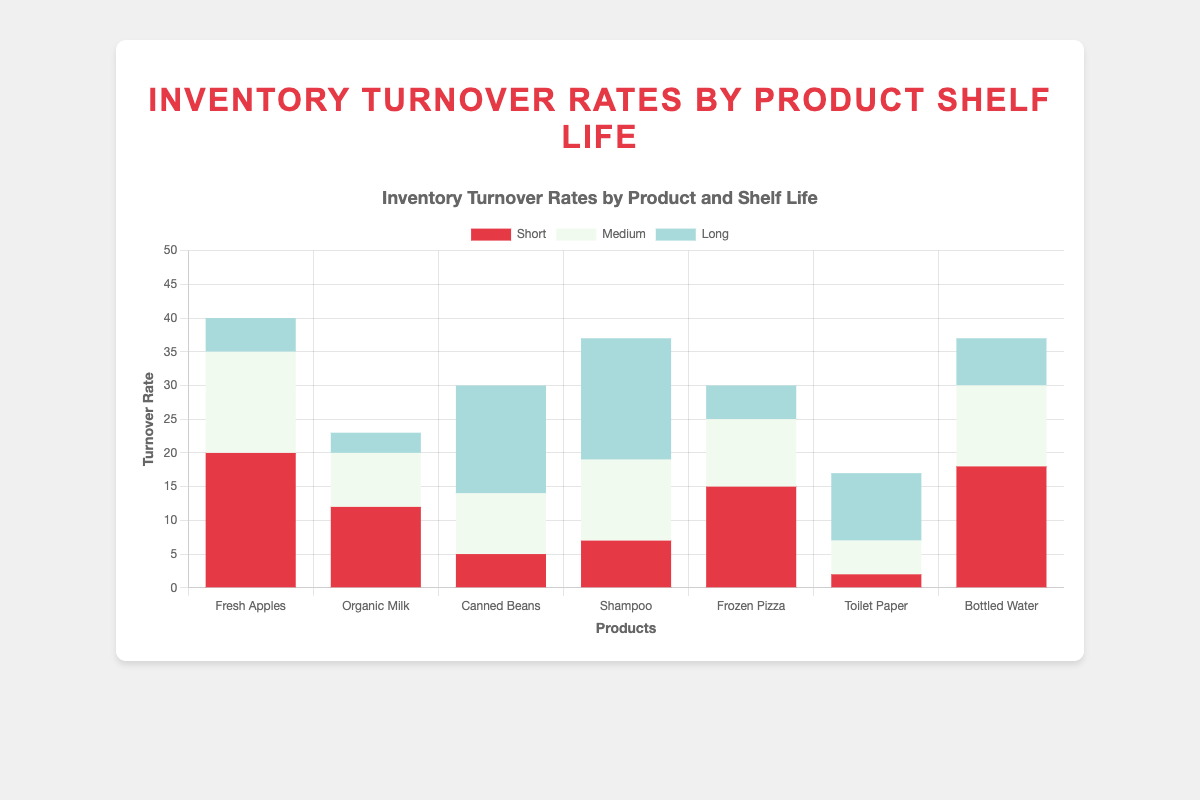What is the turnover rate for short shelf-life Fresh Apples compared to long shelf-life Fresh Apples? The turnover rate for short shelf-life Fresh Apples can be directly obtained from the chart as 20, and for long shelf-life Fresh Apples, it is 5. Comparing these two, 20 is greater than 5.
Answer: 20 is greater than 5 Which product has the highest turnover rate for short shelf-life? Scan the chart for the highest bar in the short shelf-life category, which is represented in red. Fresh Apples have a turnover rate of 20, and Bottled Water has a turnover rate of 18. The highest among them is 20, associated with Fresh Apples.
Answer: Fresh Apples What is the sum of the turnover rates for Organic Milk across all shelf-lives? Summing the turnover rates for short (12), medium (8), and long (3) shelf-lives of Organic Milk: 12 + 8 + 3 = 23
Answer: 23 Which product has the lowest turnover rate for short shelf-life, and what is it? Identify the shortest bar in the short shelf-life category (red bars). The lowest is for Toilet Paper with a rate of 2.
Answer: Toilet Paper, 2 Compare the turnover rates of Shampoo and Canned Beans for their long shelf-lives. Which is higher? For long shelf-life, Shampoo has a rate of 18 and Canned Beans have a rate of 16. Comparing these, Shampoo's rate is higher.
Answer: Shampoo What is the average turnover rate for short shelf-life products? Find the turnover rates for short shelf-life products: Fresh Apples (20), Organic Milk (12), Canned Beans (5), Shampoo (7), Frozen Pizza (15), Toilet Paper (2), Bottled Water (18). Sum them up: 20 + 12 + 5 + 7 + 15 + 2 + 18 = 79. There are 7 products, so the average is 79 / 7 ≈ 11.29.
Answer: 11.29 Which product has the highest total turnover rate across all shelf-lives? Calculate the sum of rates across all shelf-lives for each product. Fresh Apples: 20+15+5=40, Organic Milk: 12+8+3=23, Canned Beans: 5+9+16=30, Shampoo: 7+12+18=37, Frozen Pizza: 15+10+5=30, Toilet Paper: 2+5+10=17, Bottled Water: 18+12+7=37. Fresh Apples have the highest total rate of 40.
Answer: Fresh Apples How does the turnover rate for medium shelf-life Bottled Water compare to that of medium shelf-life Toilet Paper? The chart shows that the rate for medium shelf-life Bottled Water is 12, while for medium shelf-life Toilet Paper it is 5. 12 is greater than 5.
Answer: 12 is greater than 5 What is the combined turnover rate of Frozen Pizza for short and medium shelf-lives? The turnover rate for short shelf-life Frozen Pizza is 15 and for the medium shelf-life it is 10. Combined rate is 15 + 10 = 25
Answer: 25 